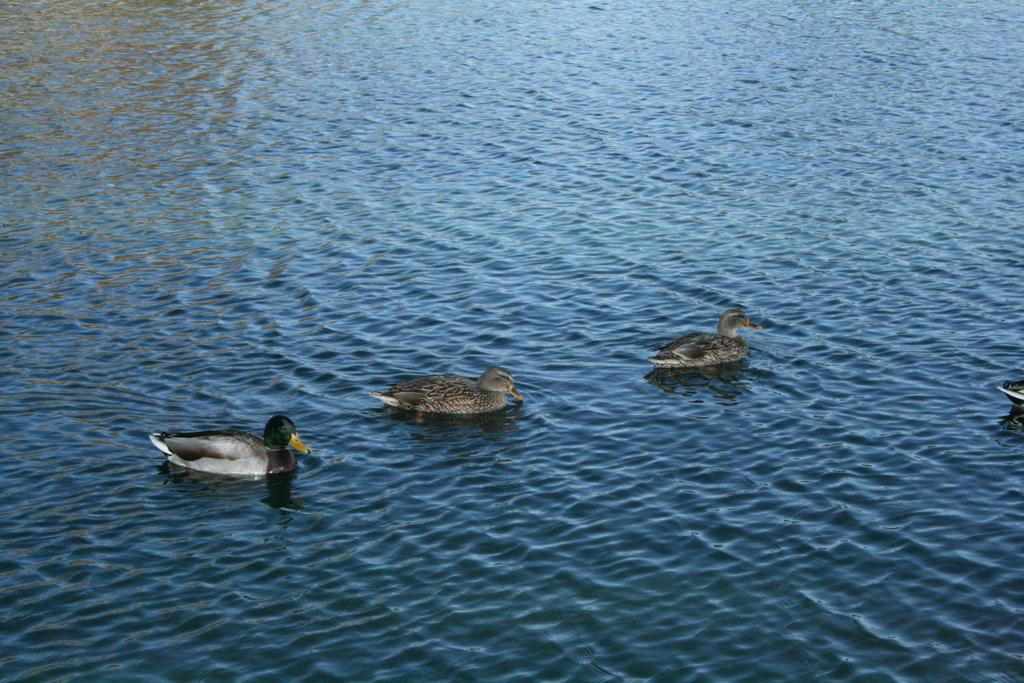Where was the image taken? The image was clicked outside the city. What can be seen in the foreground of the image? There are ducks in the water body in the foreground. What is the condition of the water body in the image? Waves are visible in the water body. How many clocks are hanging on the trees in the image? There are no clocks visible in the image; it features a water body with ducks and waves. What type of bait is being used to catch the ducks in the image? There is no indication in the image that the ducks are being caught or that bait is being used. 